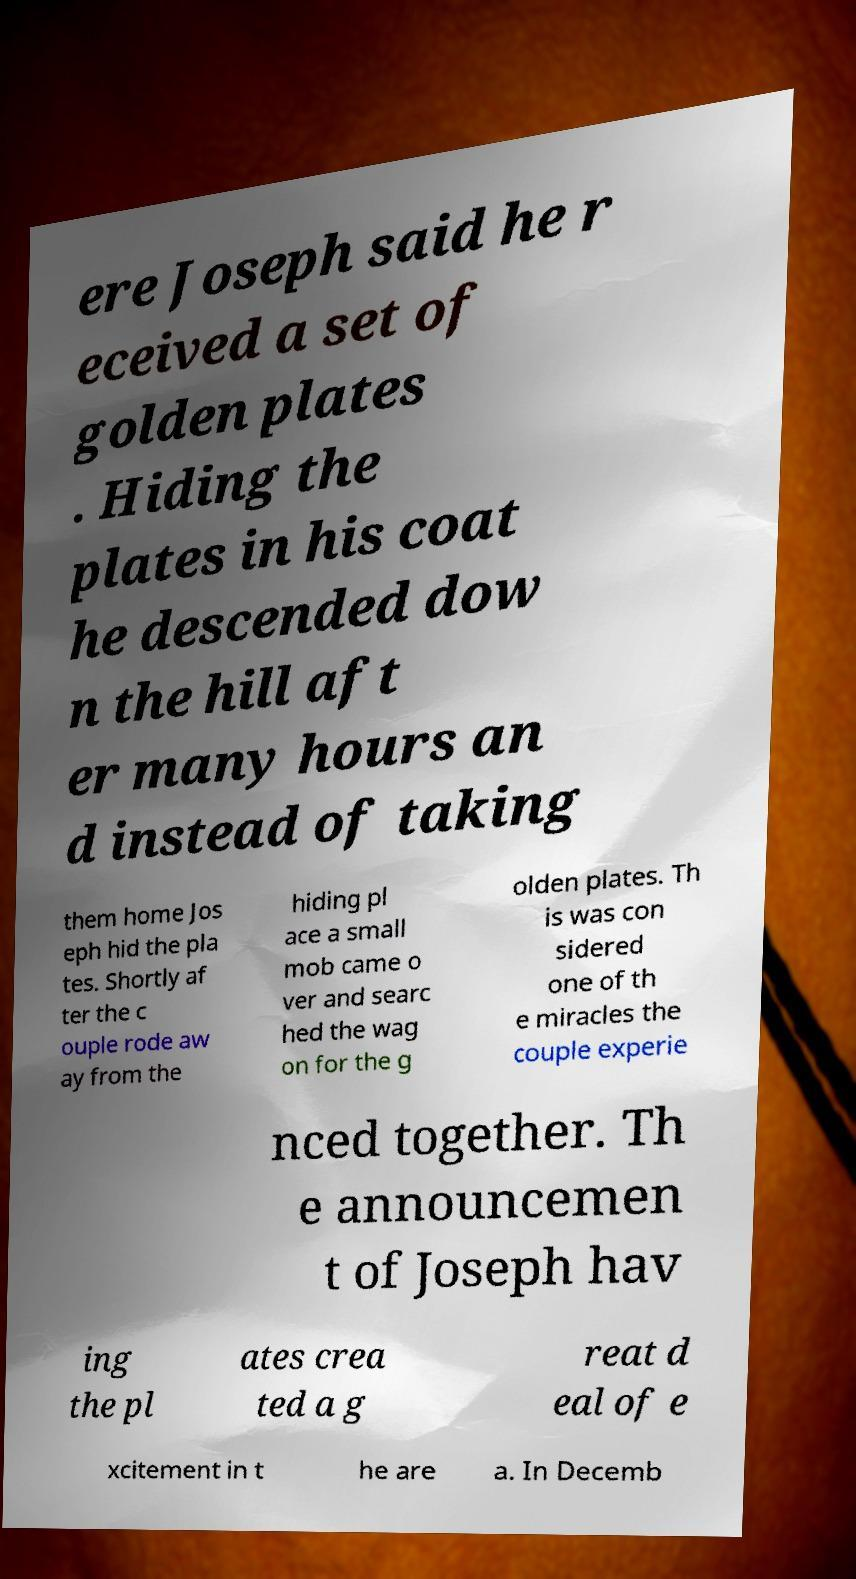For documentation purposes, I need the text within this image transcribed. Could you provide that? ere Joseph said he r eceived a set of golden plates . Hiding the plates in his coat he descended dow n the hill aft er many hours an d instead of taking them home Jos eph hid the pla tes. Shortly af ter the c ouple rode aw ay from the hiding pl ace a small mob came o ver and searc hed the wag on for the g olden plates. Th is was con sidered one of th e miracles the couple experie nced together. Th e announcemen t of Joseph hav ing the pl ates crea ted a g reat d eal of e xcitement in t he are a. In Decemb 